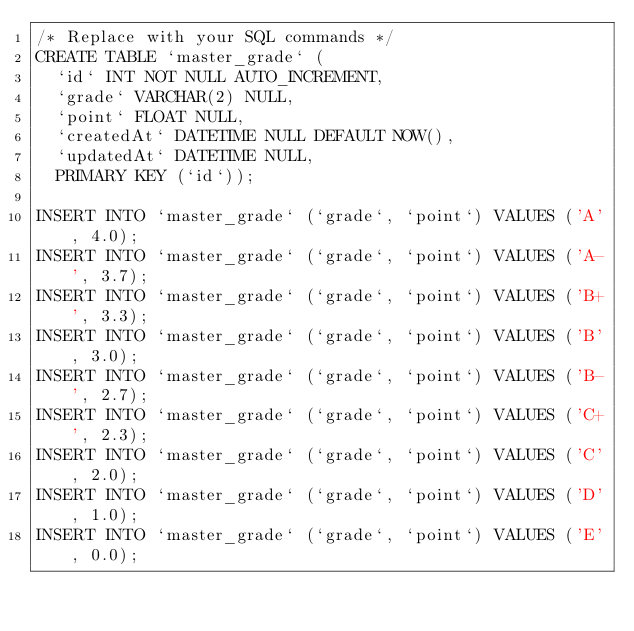<code> <loc_0><loc_0><loc_500><loc_500><_SQL_>/* Replace with your SQL commands */
CREATE TABLE `master_grade` (
  `id` INT NOT NULL AUTO_INCREMENT,
  `grade` VARCHAR(2) NULL,
  `point` FLOAT NULL,
  `createdAt` DATETIME NULL DEFAULT NOW(),
  `updatedAt` DATETIME NULL,
  PRIMARY KEY (`id`));

INSERT INTO `master_grade` (`grade`, `point`) VALUES ('A', 4.0);
INSERT INTO `master_grade` (`grade`, `point`) VALUES ('A-', 3.7);
INSERT INTO `master_grade` (`grade`, `point`) VALUES ('B+', 3.3);
INSERT INTO `master_grade` (`grade`, `point`) VALUES ('B', 3.0);
INSERT INTO `master_grade` (`grade`, `point`) VALUES ('B-', 2.7);
INSERT INTO `master_grade` (`grade`, `point`) VALUES ('C+', 2.3);
INSERT INTO `master_grade` (`grade`, `point`) VALUES ('C', 2.0);
INSERT INTO `master_grade` (`grade`, `point`) VALUES ('D', 1.0);
INSERT INTO `master_grade` (`grade`, `point`) VALUES ('E', 0.0);</code> 